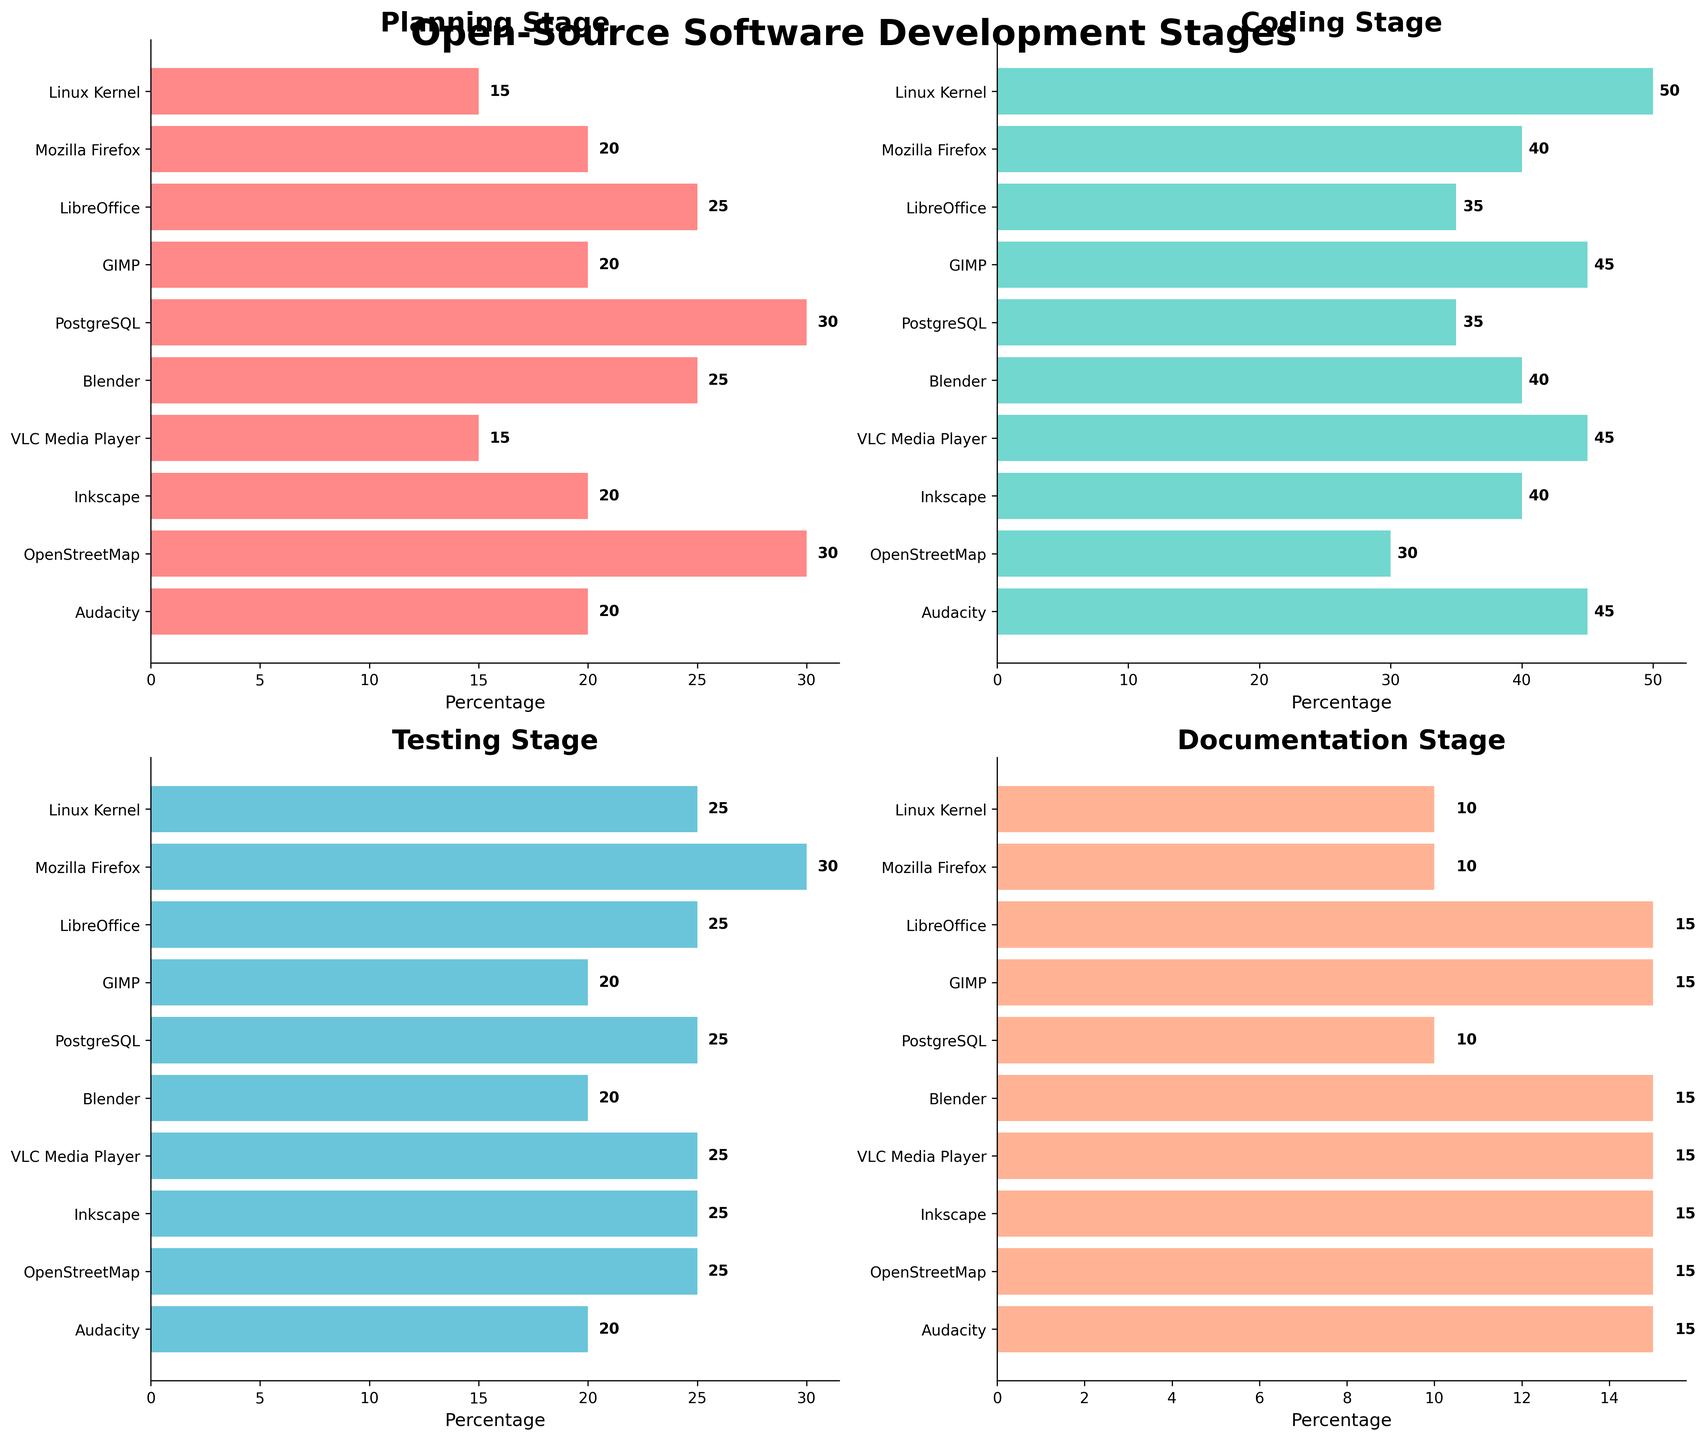How many projects have more than 40% time spent on Coding? To determine this, look at the Coding bar plot and count the number of projects with bars extending past the 40% mark. These projects are Linux Kernel, Mozilla Firefox, GIMP, VLC Media Player, Audacity.
Answer: 5 Which stage has the longest time on average across all projects? Calculate the average time for each stage: Planning (22), Coding (40.5), Testing (24.5), Documentation (13.5) by summing the respective bars and dividing by the number of projects (10).
Answer: Coding What is the total percentage of time spent on documentation for all projects combined? Sum the values for documentation from all projects: 10+10+15+15+10+15+15+15+15+15 = 125
Answer: 125 Which project has the highest percentage of time spent in the Planning stage? Identify the longest bar in the Planning subplot. This is done by comparing the bars, and PostgreSQL has the highest at 30%.
Answer: PostgreSQL Compare the time spent on Testing between LibreOffice and Blender. Which one spends more time? Look at the Testing subplot and compare the bars for LibreOffice and Blender. They both show 25%.
Answer: Both equal What's the average time spent on Testing across all projects? Sum the values from the Testing subplot: 25+30+25+20+25+20+25+25+25+20 = 240. Divide this sum by the number of projects (10).
Answer: 24 Which project spends the least amount of time on Documentation? Identify the shortest bar in the Documentation subplot. This is shared by Linux Kernel, Mozilla Firefox, and PostgreSQL, all at 10%.
Answer: Linux Kernel, Mozilla Firefox, PostgreSQL How does OpenStreetMap differ in its time allocation compared to the average for Coding? The average time spent on Coding is 40.5%. OpenStreetMap spends 30%, which is 10.5% less.
Answer: 10.5% less Which stage shows the smallest variation in time allocation across the projects? Evaluate the range of values for each stage. Documentation ranges from 10-15 (5), Testing from 20-30 (10), Planning from 15-30 (15), and Coding from 30-50 (20). Documentation has the smallest range.
Answer: Documentation 